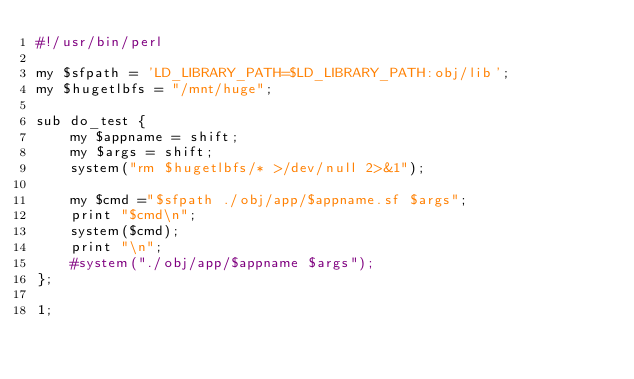Convert code to text. <code><loc_0><loc_0><loc_500><loc_500><_Perl_>#!/usr/bin/perl

my $sfpath = 'LD_LIBRARY_PATH=$LD_LIBRARY_PATH:obj/lib';
my $hugetlbfs = "/mnt/huge";

sub do_test {
    my $appname = shift;
    my $args = shift;
    system("rm $hugetlbfs/* >/dev/null 2>&1");
    
    my $cmd ="$sfpath ./obj/app/$appname.sf $args";
    print "$cmd\n";
    system($cmd);
    print "\n";
    #system("./obj/app/$appname $args");
};

1;
</code> 